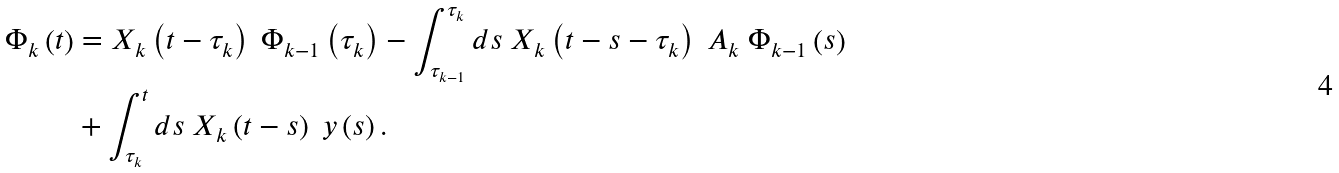<formula> <loc_0><loc_0><loc_500><loc_500>\Phi _ { k } \left ( t \right ) & = X _ { k } \left ( t - \tau _ { k } \right ) \ \Phi _ { k - 1 } \left ( \tau _ { k } \right ) - \int _ { \tau _ { k - 1 } } ^ { \tau _ { k } } d s \ X _ { k } \left ( t - s - \tau _ { k } \right ) \ A _ { k } \ \Phi _ { k - 1 } \left ( s \right ) \\ & + \int _ { \tau _ { k } } ^ { t } d s \ X _ { k } \left ( t - s \right ) \ y \left ( s \right ) .</formula> 